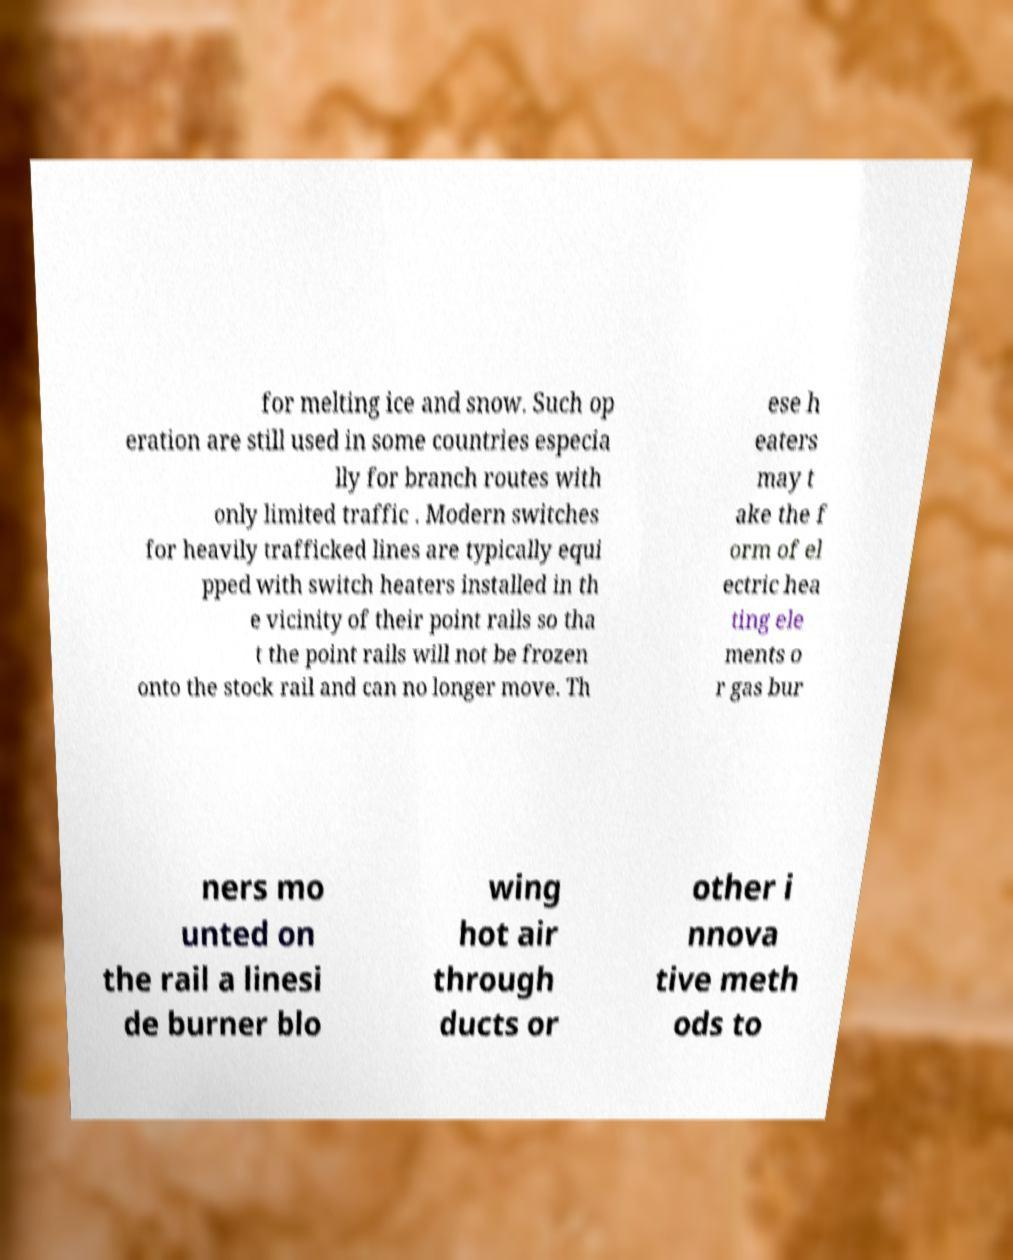Can you read and provide the text displayed in the image?This photo seems to have some interesting text. Can you extract and type it out for me? for melting ice and snow. Such op eration are still used in some countries especia lly for branch routes with only limited traffic . Modern switches for heavily trafficked lines are typically equi pped with switch heaters installed in th e vicinity of their point rails so tha t the point rails will not be frozen onto the stock rail and can no longer move. Th ese h eaters may t ake the f orm of el ectric hea ting ele ments o r gas bur ners mo unted on the rail a linesi de burner blo wing hot air through ducts or other i nnova tive meth ods to 